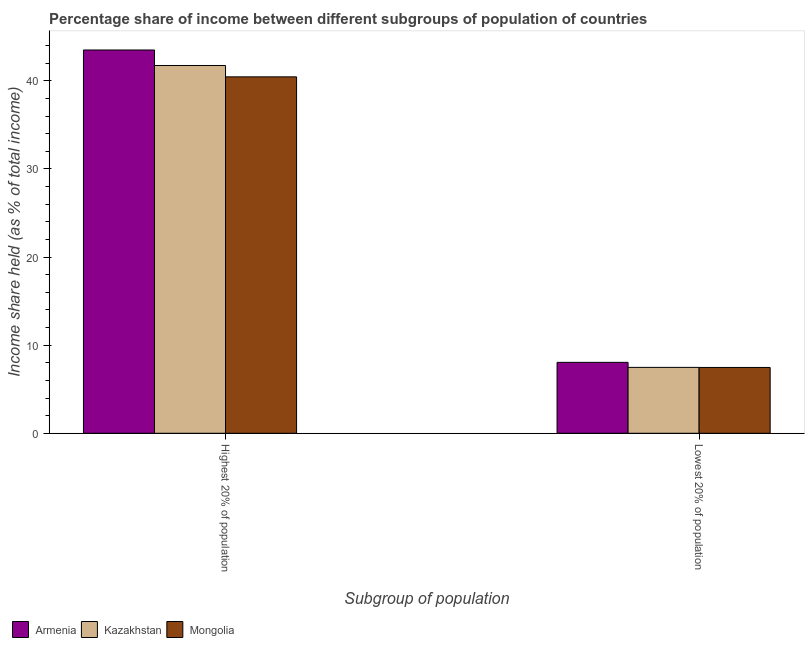How many groups of bars are there?
Offer a very short reply. 2. Are the number of bars per tick equal to the number of legend labels?
Your answer should be very brief. Yes. Are the number of bars on each tick of the X-axis equal?
Make the answer very short. Yes. How many bars are there on the 1st tick from the left?
Provide a succinct answer. 3. What is the label of the 2nd group of bars from the left?
Your response must be concise. Lowest 20% of population. What is the income share held by lowest 20% of the population in Armenia?
Your response must be concise. 8.05. Across all countries, what is the maximum income share held by highest 20% of the population?
Provide a short and direct response. 43.51. Across all countries, what is the minimum income share held by lowest 20% of the population?
Ensure brevity in your answer.  7.47. In which country was the income share held by highest 20% of the population maximum?
Ensure brevity in your answer.  Armenia. In which country was the income share held by highest 20% of the population minimum?
Offer a very short reply. Mongolia. What is the difference between the income share held by highest 20% of the population in Kazakhstan and that in Armenia?
Your answer should be very brief. -1.76. What is the difference between the income share held by lowest 20% of the population in Mongolia and the income share held by highest 20% of the population in Armenia?
Your answer should be very brief. -36.04. What is the average income share held by lowest 20% of the population per country?
Give a very brief answer. 7.67. What is the difference between the income share held by highest 20% of the population and income share held by lowest 20% of the population in Armenia?
Your response must be concise. 35.46. What is the ratio of the income share held by highest 20% of the population in Armenia to that in Mongolia?
Offer a very short reply. 1.08. What does the 1st bar from the left in Highest 20% of population represents?
Give a very brief answer. Armenia. What does the 1st bar from the right in Highest 20% of population represents?
Your answer should be very brief. Mongolia. How many countries are there in the graph?
Ensure brevity in your answer.  3. What is the difference between two consecutive major ticks on the Y-axis?
Offer a terse response. 10. How many legend labels are there?
Provide a short and direct response. 3. What is the title of the graph?
Provide a short and direct response. Percentage share of income between different subgroups of population of countries. Does "Venezuela" appear as one of the legend labels in the graph?
Make the answer very short. No. What is the label or title of the X-axis?
Provide a short and direct response. Subgroup of population. What is the label or title of the Y-axis?
Keep it short and to the point. Income share held (as % of total income). What is the Income share held (as % of total income) in Armenia in Highest 20% of population?
Offer a very short reply. 43.51. What is the Income share held (as % of total income) of Kazakhstan in Highest 20% of population?
Offer a very short reply. 41.75. What is the Income share held (as % of total income) in Mongolia in Highest 20% of population?
Your answer should be compact. 40.46. What is the Income share held (as % of total income) in Armenia in Lowest 20% of population?
Keep it short and to the point. 8.05. What is the Income share held (as % of total income) in Kazakhstan in Lowest 20% of population?
Ensure brevity in your answer.  7.48. What is the Income share held (as % of total income) in Mongolia in Lowest 20% of population?
Offer a terse response. 7.47. Across all Subgroup of population, what is the maximum Income share held (as % of total income) in Armenia?
Offer a terse response. 43.51. Across all Subgroup of population, what is the maximum Income share held (as % of total income) in Kazakhstan?
Offer a very short reply. 41.75. Across all Subgroup of population, what is the maximum Income share held (as % of total income) in Mongolia?
Your answer should be compact. 40.46. Across all Subgroup of population, what is the minimum Income share held (as % of total income) of Armenia?
Provide a short and direct response. 8.05. Across all Subgroup of population, what is the minimum Income share held (as % of total income) in Kazakhstan?
Ensure brevity in your answer.  7.48. Across all Subgroup of population, what is the minimum Income share held (as % of total income) of Mongolia?
Keep it short and to the point. 7.47. What is the total Income share held (as % of total income) of Armenia in the graph?
Provide a succinct answer. 51.56. What is the total Income share held (as % of total income) in Kazakhstan in the graph?
Your answer should be compact. 49.23. What is the total Income share held (as % of total income) in Mongolia in the graph?
Your answer should be compact. 47.93. What is the difference between the Income share held (as % of total income) in Armenia in Highest 20% of population and that in Lowest 20% of population?
Offer a very short reply. 35.46. What is the difference between the Income share held (as % of total income) in Kazakhstan in Highest 20% of population and that in Lowest 20% of population?
Provide a short and direct response. 34.27. What is the difference between the Income share held (as % of total income) of Mongolia in Highest 20% of population and that in Lowest 20% of population?
Make the answer very short. 32.99. What is the difference between the Income share held (as % of total income) of Armenia in Highest 20% of population and the Income share held (as % of total income) of Kazakhstan in Lowest 20% of population?
Give a very brief answer. 36.03. What is the difference between the Income share held (as % of total income) in Armenia in Highest 20% of population and the Income share held (as % of total income) in Mongolia in Lowest 20% of population?
Keep it short and to the point. 36.04. What is the difference between the Income share held (as % of total income) in Kazakhstan in Highest 20% of population and the Income share held (as % of total income) in Mongolia in Lowest 20% of population?
Your answer should be very brief. 34.28. What is the average Income share held (as % of total income) in Armenia per Subgroup of population?
Keep it short and to the point. 25.78. What is the average Income share held (as % of total income) of Kazakhstan per Subgroup of population?
Provide a succinct answer. 24.61. What is the average Income share held (as % of total income) in Mongolia per Subgroup of population?
Keep it short and to the point. 23.96. What is the difference between the Income share held (as % of total income) in Armenia and Income share held (as % of total income) in Kazakhstan in Highest 20% of population?
Your response must be concise. 1.76. What is the difference between the Income share held (as % of total income) in Armenia and Income share held (as % of total income) in Mongolia in Highest 20% of population?
Offer a terse response. 3.05. What is the difference between the Income share held (as % of total income) in Kazakhstan and Income share held (as % of total income) in Mongolia in Highest 20% of population?
Your response must be concise. 1.29. What is the difference between the Income share held (as % of total income) of Armenia and Income share held (as % of total income) of Kazakhstan in Lowest 20% of population?
Offer a terse response. 0.57. What is the difference between the Income share held (as % of total income) in Armenia and Income share held (as % of total income) in Mongolia in Lowest 20% of population?
Make the answer very short. 0.58. What is the difference between the Income share held (as % of total income) in Kazakhstan and Income share held (as % of total income) in Mongolia in Lowest 20% of population?
Give a very brief answer. 0.01. What is the ratio of the Income share held (as % of total income) in Armenia in Highest 20% of population to that in Lowest 20% of population?
Provide a succinct answer. 5.41. What is the ratio of the Income share held (as % of total income) of Kazakhstan in Highest 20% of population to that in Lowest 20% of population?
Ensure brevity in your answer.  5.58. What is the ratio of the Income share held (as % of total income) in Mongolia in Highest 20% of population to that in Lowest 20% of population?
Keep it short and to the point. 5.42. What is the difference between the highest and the second highest Income share held (as % of total income) of Armenia?
Offer a terse response. 35.46. What is the difference between the highest and the second highest Income share held (as % of total income) in Kazakhstan?
Keep it short and to the point. 34.27. What is the difference between the highest and the second highest Income share held (as % of total income) in Mongolia?
Give a very brief answer. 32.99. What is the difference between the highest and the lowest Income share held (as % of total income) in Armenia?
Give a very brief answer. 35.46. What is the difference between the highest and the lowest Income share held (as % of total income) of Kazakhstan?
Ensure brevity in your answer.  34.27. What is the difference between the highest and the lowest Income share held (as % of total income) in Mongolia?
Offer a terse response. 32.99. 